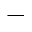<formula> <loc_0><loc_0><loc_500><loc_500>^ { - }</formula> 